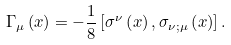<formula> <loc_0><loc_0><loc_500><loc_500>\Gamma _ { \mu } \left ( x \right ) = - \frac { 1 } { 8 } \left [ \sigma ^ { \nu } \left ( x \right ) , \sigma _ { \nu ; \mu } \left ( x \right ) \right ] .</formula> 